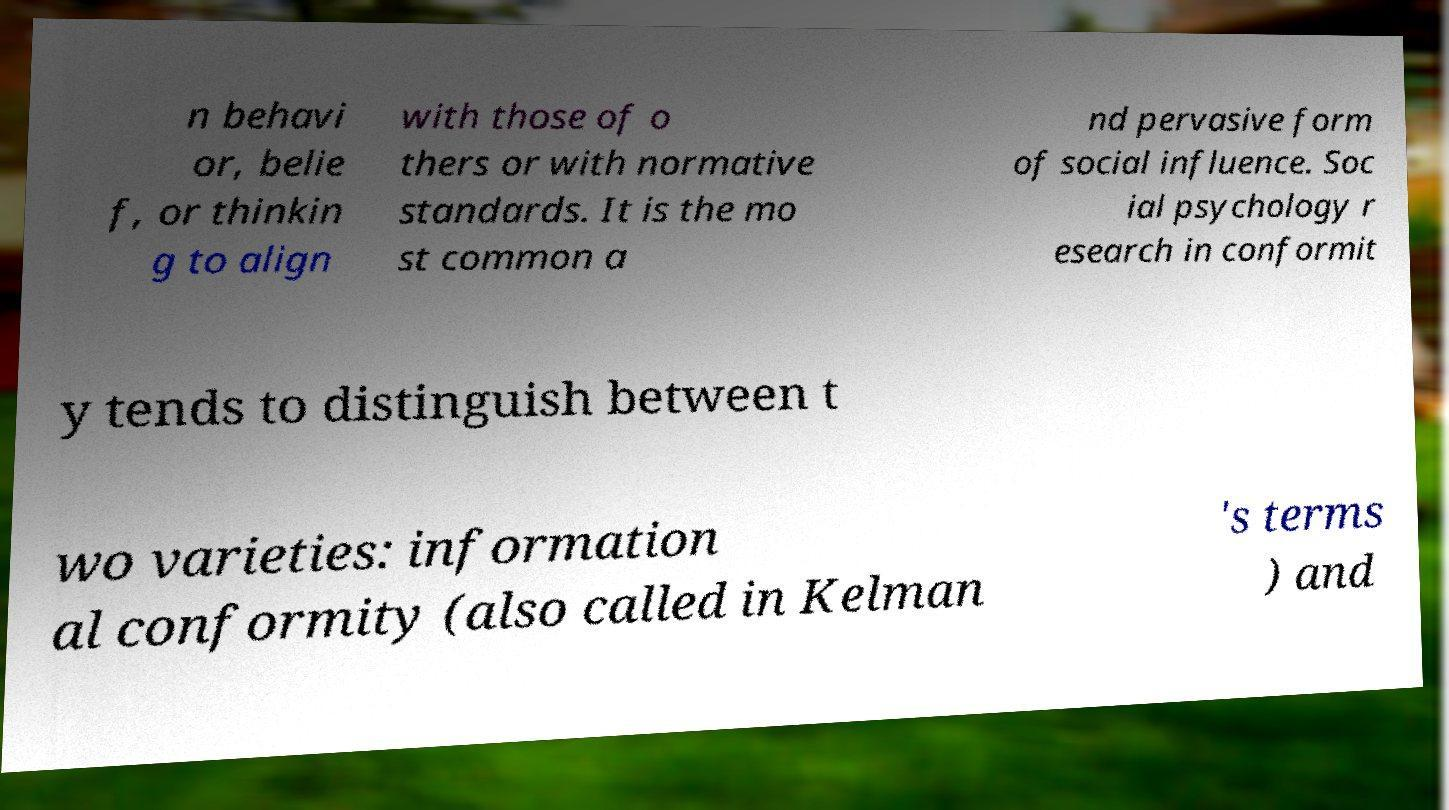Can you accurately transcribe the text from the provided image for me? n behavi or, belie f, or thinkin g to align with those of o thers or with normative standards. It is the mo st common a nd pervasive form of social influence. Soc ial psychology r esearch in conformit y tends to distinguish between t wo varieties: information al conformity (also called in Kelman 's terms ) and 